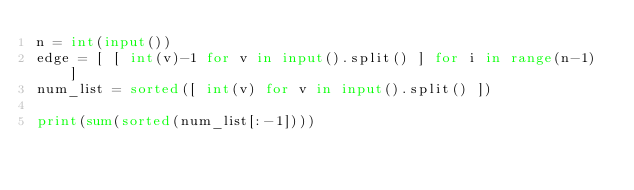<code> <loc_0><loc_0><loc_500><loc_500><_Python_>n = int(input())
edge = [ [ int(v)-1 for v in input().split() ] for i in range(n-1) ]
num_list = sorted([ int(v) for v in input().split() ])

print(sum(sorted(num_list[:-1])))</code> 